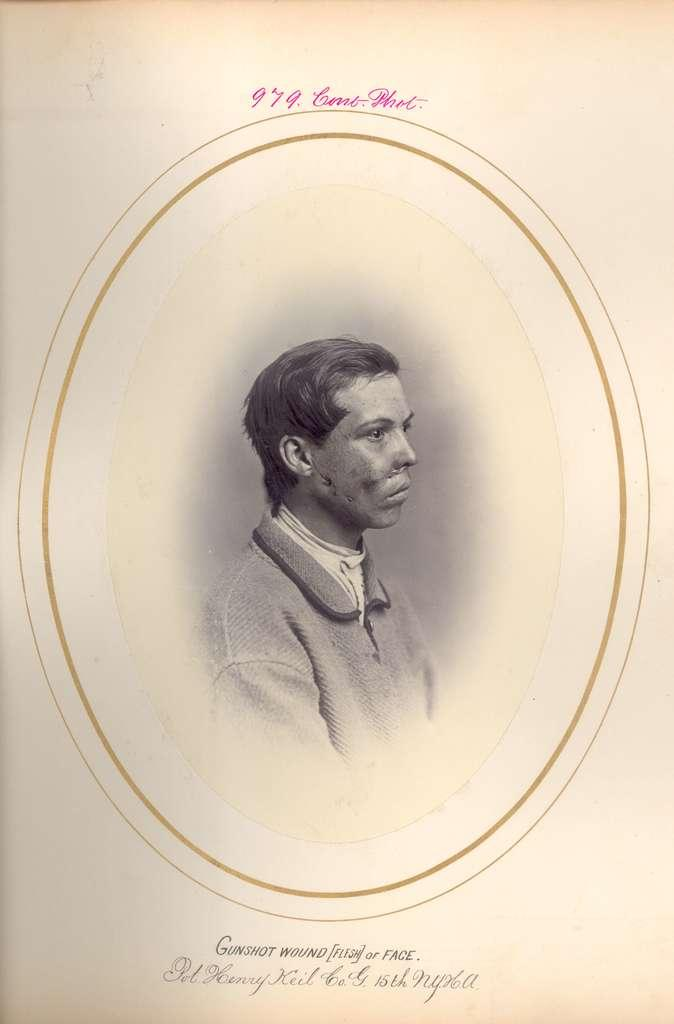What is the main subject of the image? The main subject of the image is a frame. How many hills can be seen in the image? There are no hills present in the image; it only features a frame. What type of match is being used in the image? There is no match present in the image; it only features a frame. 